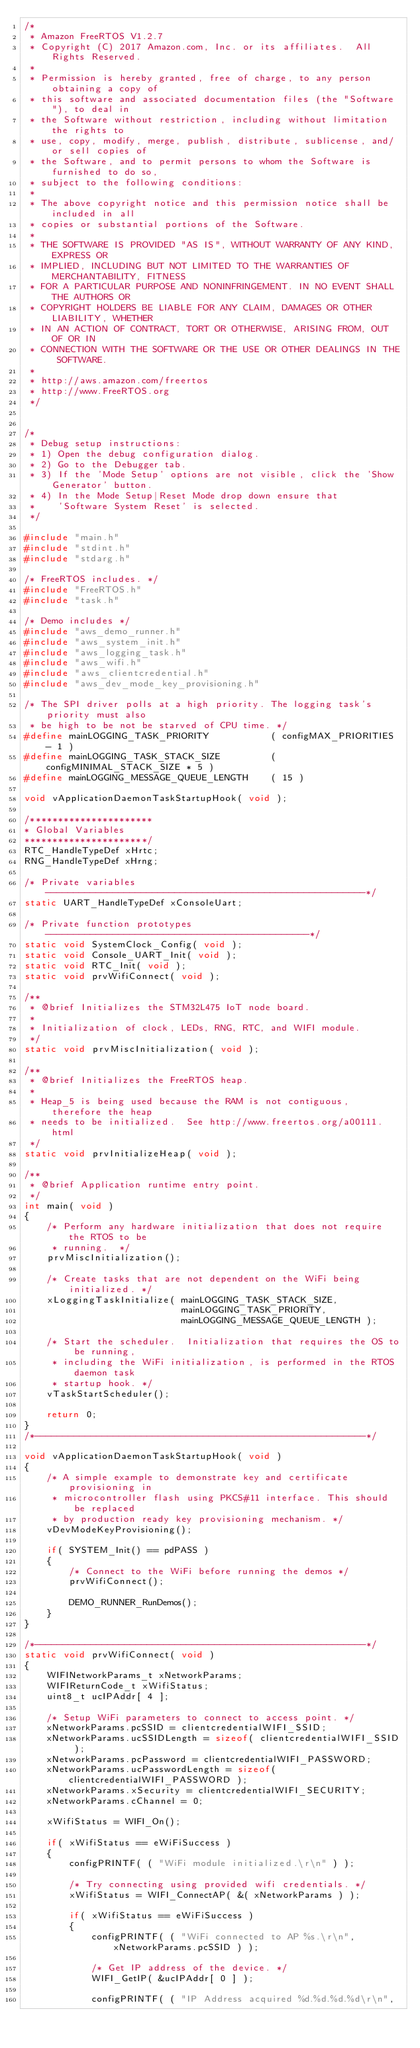<code> <loc_0><loc_0><loc_500><loc_500><_C_>/*
 * Amazon FreeRTOS V1.2.7
 * Copyright (C) 2017 Amazon.com, Inc. or its affiliates.  All Rights Reserved.
 *
 * Permission is hereby granted, free of charge, to any person obtaining a copy of
 * this software and associated documentation files (the "Software"), to deal in
 * the Software without restriction, including without limitation the rights to
 * use, copy, modify, merge, publish, distribute, sublicense, and/or sell copies of
 * the Software, and to permit persons to whom the Software is furnished to do so,
 * subject to the following conditions:
 *
 * The above copyright notice and this permission notice shall be included in all
 * copies or substantial portions of the Software.
 *
 * THE SOFTWARE IS PROVIDED "AS IS", WITHOUT WARRANTY OF ANY KIND, EXPRESS OR
 * IMPLIED, INCLUDING BUT NOT LIMITED TO THE WARRANTIES OF MERCHANTABILITY, FITNESS
 * FOR A PARTICULAR PURPOSE AND NONINFRINGEMENT. IN NO EVENT SHALL THE AUTHORS OR
 * COPYRIGHT HOLDERS BE LIABLE FOR ANY CLAIM, DAMAGES OR OTHER LIABILITY, WHETHER
 * IN AN ACTION OF CONTRACT, TORT OR OTHERWISE, ARISING FROM, OUT OF OR IN
 * CONNECTION WITH THE SOFTWARE OR THE USE OR OTHER DEALINGS IN THE SOFTWARE.
 *
 * http://aws.amazon.com/freertos
 * http://www.FreeRTOS.org
 */


/*
 * Debug setup instructions:
 * 1) Open the debug configuration dialog.
 * 2) Go to the Debugger tab.
 * 3) If the 'Mode Setup' options are not visible, click the 'Show Generator' button.
 * 4) In the Mode Setup|Reset Mode drop down ensure that
 *    'Software System Reset' is selected.
 */

#include "main.h"
#include "stdint.h"
#include "stdarg.h"

/* FreeRTOS includes. */
#include "FreeRTOS.h"
#include "task.h"

/* Demo includes */
#include "aws_demo_runner.h"
#include "aws_system_init.h"
#include "aws_logging_task.h"
#include "aws_wifi.h"
#include "aws_clientcredential.h"
#include "aws_dev_mode_key_provisioning.h"

/* The SPI driver polls at a high priority. The logging task's priority must also
 * be high to be not be starved of CPU time. */
#define mainLOGGING_TASK_PRIORITY           ( configMAX_PRIORITIES - 1 )
#define mainLOGGING_TASK_STACK_SIZE         ( configMINIMAL_STACK_SIZE * 5 )
#define mainLOGGING_MESSAGE_QUEUE_LENGTH    ( 15 )

void vApplicationDaemonTaskStartupHook( void );

/**********************
* Global Variables
**********************/
RTC_HandleTypeDef xHrtc;
RNG_HandleTypeDef xHrng;

/* Private variables ---------------------------------------------------------*/
static UART_HandleTypeDef xConsoleUart;

/* Private function prototypes -----------------------------------------------*/
static void SystemClock_Config( void );
static void Console_UART_Init( void );
static void RTC_Init( void );
static void prvWifiConnect( void );

/**
 * @brief Initializes the STM32L475 IoT node board.
 *
 * Initialization of clock, LEDs, RNG, RTC, and WIFI module.
 */
static void prvMiscInitialization( void );

/**
 * @brief Initializes the FreeRTOS heap.
 *
 * Heap_5 is being used because the RAM is not contiguous, therefore the heap
 * needs to be initialized.  See http://www.freertos.org/a00111.html
 */
static void prvInitializeHeap( void );

/**
 * @brief Application runtime entry point.
 */
int main( void )
{
    /* Perform any hardware initialization that does not require the RTOS to be
     * running.  */
    prvMiscInitialization();

    /* Create tasks that are not dependent on the WiFi being initialized. */
    xLoggingTaskInitialize( mainLOGGING_TASK_STACK_SIZE,
                            mainLOGGING_TASK_PRIORITY,
                            mainLOGGING_MESSAGE_QUEUE_LENGTH );

    /* Start the scheduler.  Initialization that requires the OS to be running,
     * including the WiFi initialization, is performed in the RTOS daemon task
     * startup hook. */
    vTaskStartScheduler();

    return 0;
}
/*-----------------------------------------------------------*/

void vApplicationDaemonTaskStartupHook( void )
{
    /* A simple example to demonstrate key and certificate provisioning in
     * microcontroller flash using PKCS#11 interface. This should be replaced
     * by production ready key provisioning mechanism. */
    vDevModeKeyProvisioning();

    if( SYSTEM_Init() == pdPASS )
    {
        /* Connect to the WiFi before running the demos */
        prvWifiConnect();

        DEMO_RUNNER_RunDemos();
    }
}

/*-----------------------------------------------------------*/
static void prvWifiConnect( void )
{
    WIFINetworkParams_t xNetworkParams;
    WIFIReturnCode_t xWifiStatus;
    uint8_t ucIPAddr[ 4 ];

    /* Setup WiFi parameters to connect to access point. */
    xNetworkParams.pcSSID = clientcredentialWIFI_SSID;
    xNetworkParams.ucSSIDLength = sizeof( clientcredentialWIFI_SSID );
    xNetworkParams.pcPassword = clientcredentialWIFI_PASSWORD;
    xNetworkParams.ucPasswordLength = sizeof( clientcredentialWIFI_PASSWORD );
    xNetworkParams.xSecurity = clientcredentialWIFI_SECURITY;
    xNetworkParams.cChannel = 0;

    xWifiStatus = WIFI_On();

    if( xWifiStatus == eWiFiSuccess )
    {
        configPRINTF( ( "WiFi module initialized.\r\n" ) );

        /* Try connecting using provided wifi credentials. */
        xWifiStatus = WIFI_ConnectAP( &( xNetworkParams ) );

        if( xWifiStatus == eWiFiSuccess )
        {
            configPRINTF( ( "WiFi connected to AP %s.\r\n", xNetworkParams.pcSSID ) );

            /* Get IP address of the device. */
            WIFI_GetIP( &ucIPAddr[ 0 ] );

            configPRINTF( ( "IP Address acquired %d.%d.%d.%d\r\n",</code> 